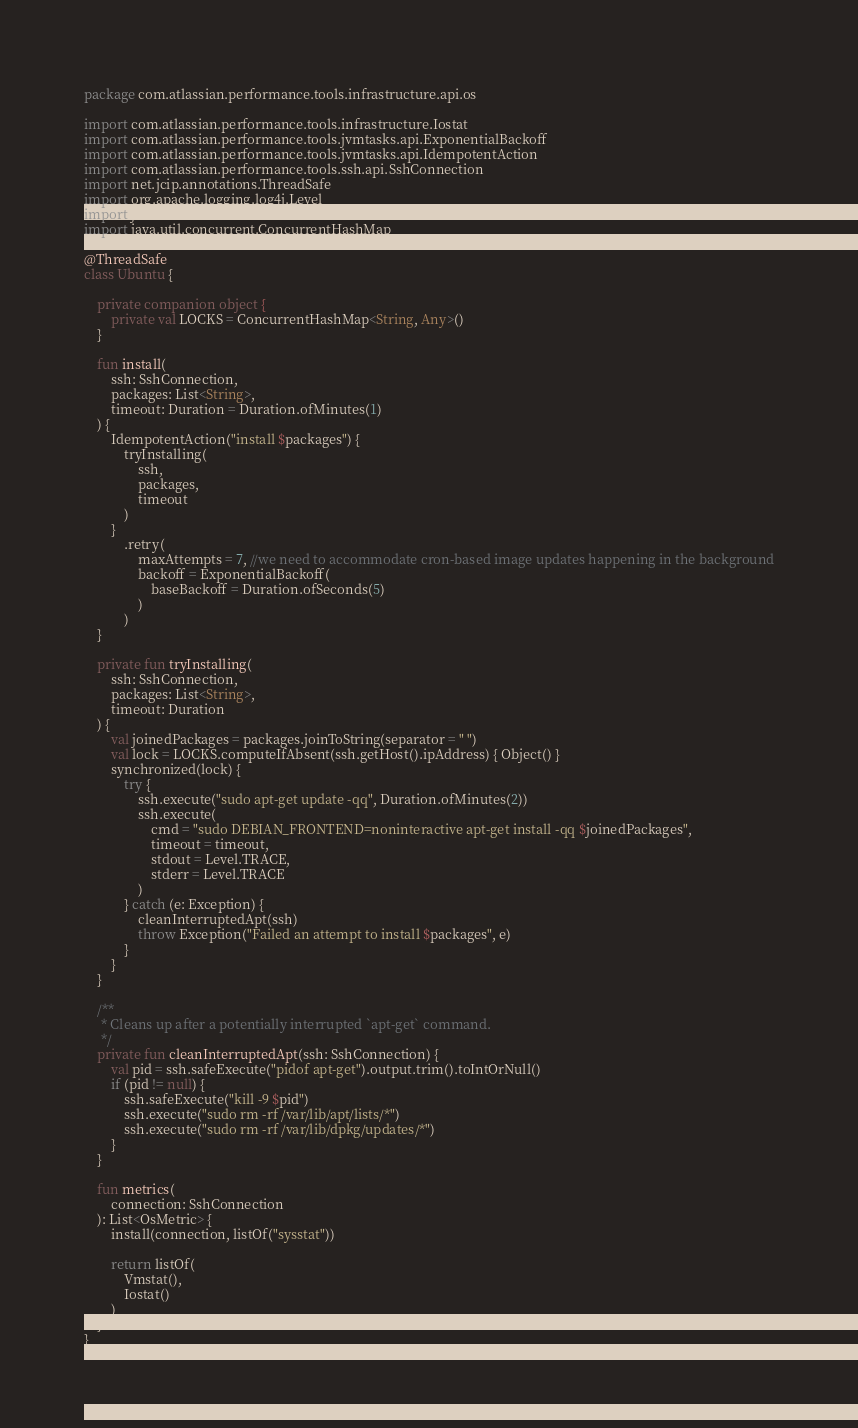<code> <loc_0><loc_0><loc_500><loc_500><_Kotlin_>package com.atlassian.performance.tools.infrastructure.api.os

import com.atlassian.performance.tools.infrastructure.Iostat
import com.atlassian.performance.tools.jvmtasks.api.ExponentialBackoff
import com.atlassian.performance.tools.jvmtasks.api.IdempotentAction
import com.atlassian.performance.tools.ssh.api.SshConnection
import net.jcip.annotations.ThreadSafe
import org.apache.logging.log4j.Level
import java.time.Duration
import java.util.concurrent.ConcurrentHashMap

@ThreadSafe
class Ubuntu {

    private companion object {
        private val LOCKS = ConcurrentHashMap<String, Any>()
    }

    fun install(
        ssh: SshConnection,
        packages: List<String>,
        timeout: Duration = Duration.ofMinutes(1)
    ) {
        IdempotentAction("install $packages") {
            tryInstalling(
                ssh,
                packages,
                timeout
            )
        }
            .retry(
                maxAttempts = 7, //we need to accommodate cron-based image updates happening in the background
                backoff = ExponentialBackoff(
                    baseBackoff = Duration.ofSeconds(5)
                )
            )
    }

    private fun tryInstalling(
        ssh: SshConnection,
        packages: List<String>,
        timeout: Duration
    ) {
        val joinedPackages = packages.joinToString(separator = " ")
        val lock = LOCKS.computeIfAbsent(ssh.getHost().ipAddress) { Object() }
        synchronized(lock) {
            try {
                ssh.execute("sudo apt-get update -qq", Duration.ofMinutes(2))
                ssh.execute(
                    cmd = "sudo DEBIAN_FRONTEND=noninteractive apt-get install -qq $joinedPackages",
                    timeout = timeout,
                    stdout = Level.TRACE,
                    stderr = Level.TRACE
                )
            } catch (e: Exception) {
                cleanInterruptedApt(ssh)
                throw Exception("Failed an attempt to install $packages", e)
            }
        }
    }

    /**
     * Cleans up after a potentially interrupted `apt-get` command.
     */
    private fun cleanInterruptedApt(ssh: SshConnection) {
        val pid = ssh.safeExecute("pidof apt-get").output.trim().toIntOrNull()
        if (pid != null) {
            ssh.safeExecute("kill -9 $pid")
            ssh.execute("sudo rm -rf /var/lib/apt/lists/*")
            ssh.execute("sudo rm -rf /var/lib/dpkg/updates/*")
        }
    }

    fun metrics(
        connection: SshConnection
    ): List<OsMetric> {
        install(connection, listOf("sysstat"))

        return listOf(
            Vmstat(),
            Iostat()
        )
    }
}
</code> 